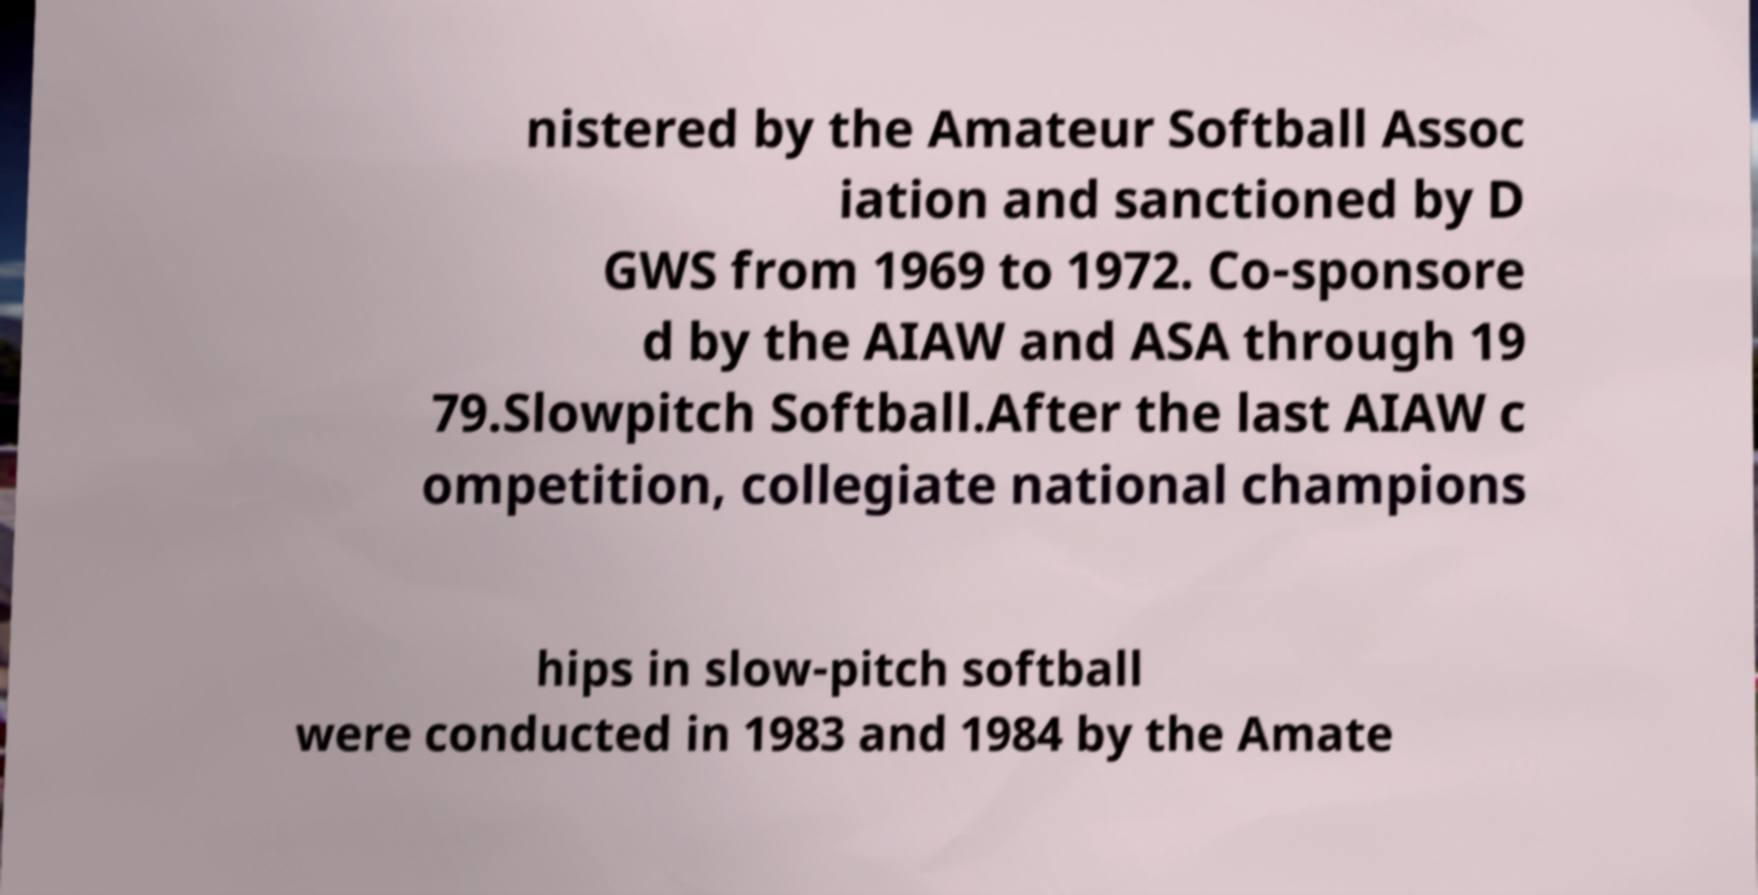Could you extract and type out the text from this image? nistered by the Amateur Softball Assoc iation and sanctioned by D GWS from 1969 to 1972. Co-sponsore d by the AIAW and ASA through 19 79.Slowpitch Softball.After the last AIAW c ompetition, collegiate national champions hips in slow-pitch softball were conducted in 1983 and 1984 by the Amate 